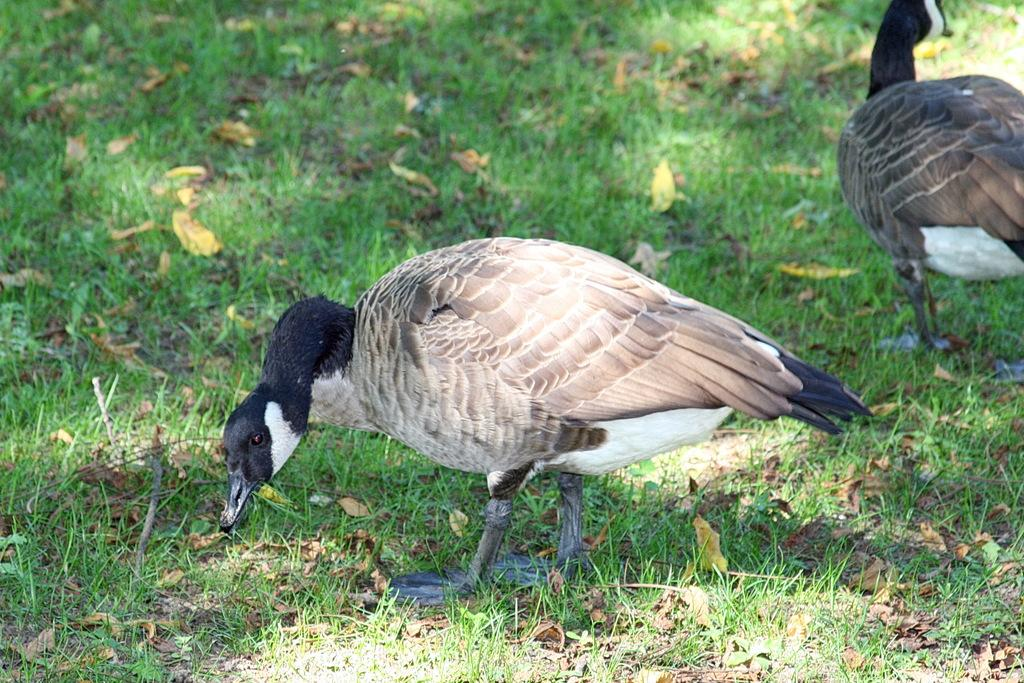What type of animals can be seen in the image? There are two birds on the ground in the image. What type of vegetation is visible in the image? There is grass visible in the image. What additional natural elements can be seen in the image? There are dried leaves in the image. What type of pie is being served to the birds in the image? There is no pie present in the image; it features two birds on the ground and natural elements such as grass and dried leaves. 